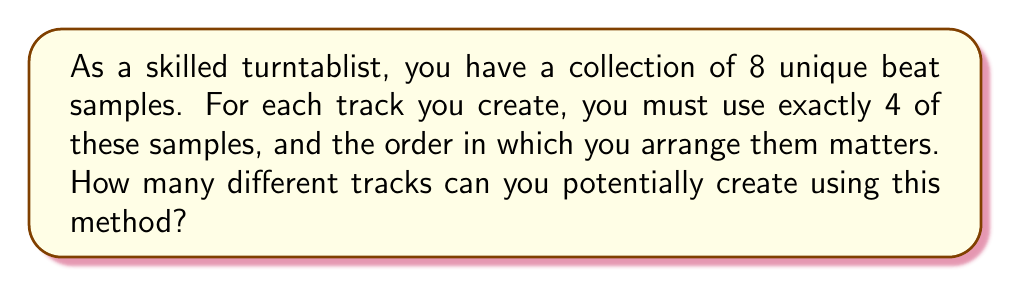Provide a solution to this math problem. Let's approach this step-by-step using combinatorics:

1) We are selecting 4 samples out of 8, where the order matters. This scenario is a permutation.

2) We use the permutation formula:
   $$P(n,r) = \frac{n!}{(n-r)!}$$
   where $n$ is the total number of items to choose from, and $r$ is the number of items being chosen.

3) In this case, $n = 8$ (total samples) and $r = 4$ (samples used in each track).

4) Plugging these values into the formula:
   $$P(8,4) = \frac{8!}{(8-4)!} = \frac{8!}{4!}$$

5) Expanding this:
   $$\frac{8 \times 7 \times 6 \times 5 \times 4!}{4!}$$

6) The $4!$ cancels out in the numerator and denominator:
   $$8 \times 7 \times 6 \times 5 = 1680$$

Therefore, you can create 1680 different tracks using this method.
Answer: 1680 